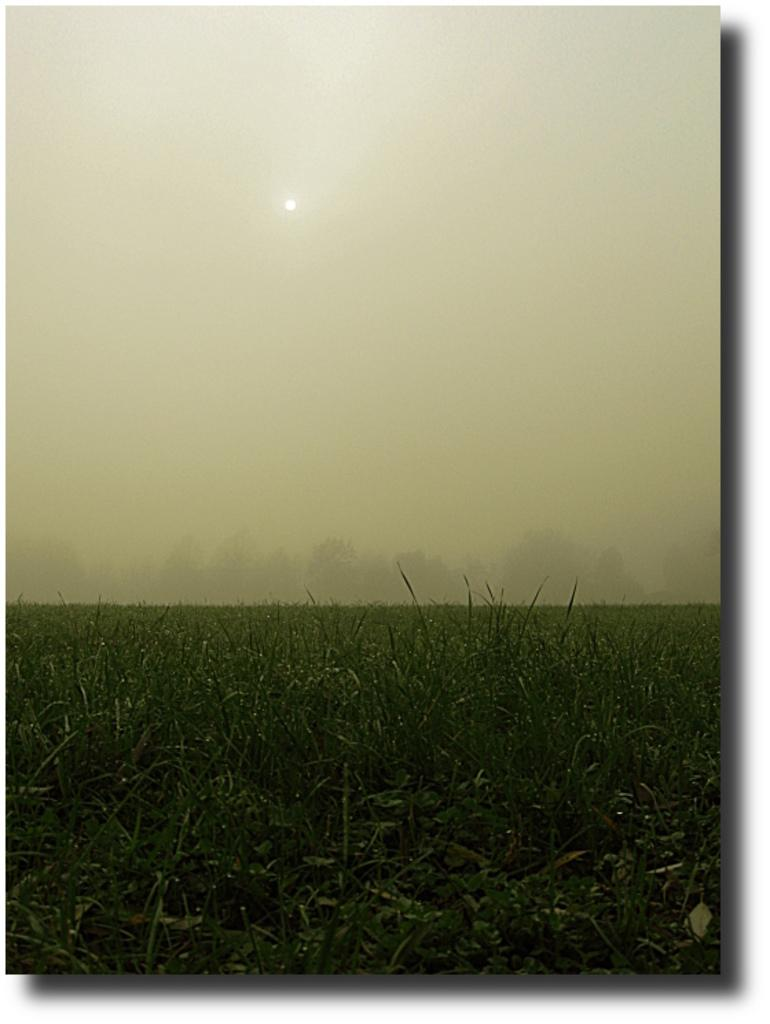What color is the grass in the image? The grass in the image is green. What can be seen in the background of the image? The sky in the background of the image is white. What type of advertisement is being read by the voice in the image? There is no voice or advertisement present in the image; it only features green grass and a white sky. What prose is being recited by the voice in the image? There is no voice or prose present in the image; it only features green grass and a white sky. 